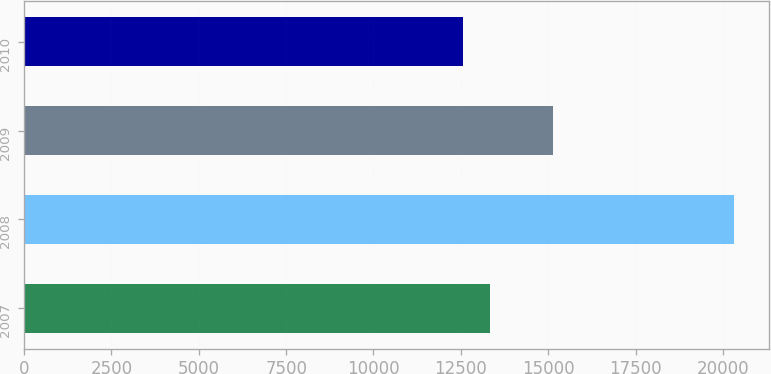<chart> <loc_0><loc_0><loc_500><loc_500><bar_chart><fcel>2007<fcel>2008<fcel>2009<fcel>2010<nl><fcel>13341.6<fcel>20304<fcel>15133<fcel>12568<nl></chart> 